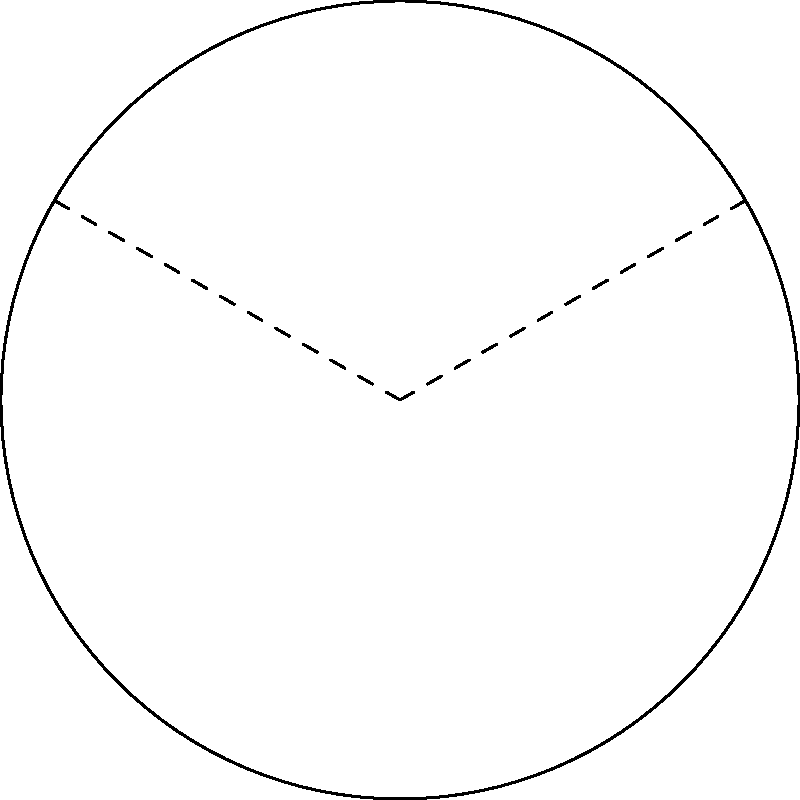During a hurricane evacuation, you need to plan a curved route along a circular perimeter. The route starts at point A and ends at point B, forming a central angle of 120° with the center O. If the radius of the circular perimeter is 3 miles, what is the length of the evacuation route along the arc from A to B? To find the length of the evacuation route along the arc, we need to follow these steps:

1) Recall the formula for arc length: $s = r\theta$
   Where $s$ is the arc length, $r$ is the radius, and $\theta$ is the central angle in radians.

2) We're given the radius $r = 3$ miles and the central angle is 120°.

3) Convert the central angle from degrees to radians:
   $\theta = 120° \times \frac{\pi}{180°} = \frac{2\pi}{3}$ radians

4) Now, substitute these values into the arc length formula:
   $s = r\theta = 3 \times \frac{2\pi}{3} = 2\pi$ miles

5) To get a decimal approximation:
   $s \approx 2 \times 3.14159 \approx 6.28$ miles

Therefore, the length of the evacuation route along the arc from A to B is $2\pi$ miles or approximately 6.28 miles.
Answer: $2\pi$ miles 